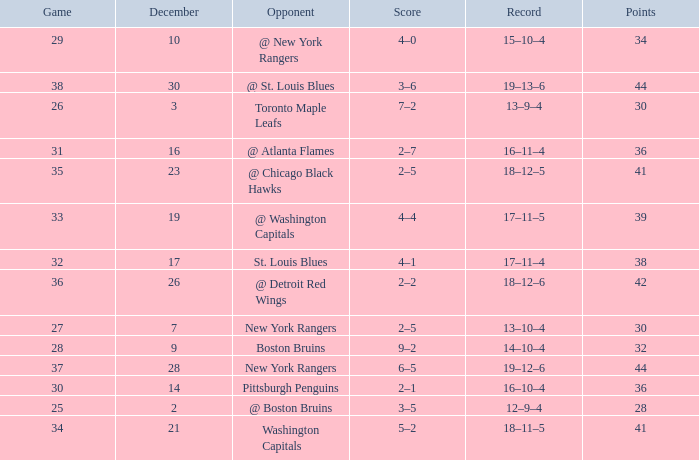Which Score has Points of 36, and a Game of 30? 2–1. 